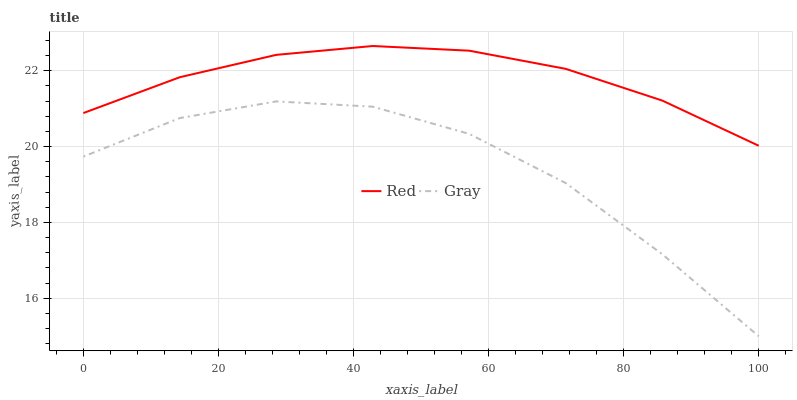Does Gray have the minimum area under the curve?
Answer yes or no. Yes. Does Red have the maximum area under the curve?
Answer yes or no. Yes. Does Red have the minimum area under the curve?
Answer yes or no. No. Is Red the smoothest?
Answer yes or no. Yes. Is Gray the roughest?
Answer yes or no. Yes. Is Red the roughest?
Answer yes or no. No. Does Gray have the lowest value?
Answer yes or no. Yes. Does Red have the lowest value?
Answer yes or no. No. Does Red have the highest value?
Answer yes or no. Yes. Is Gray less than Red?
Answer yes or no. Yes. Is Red greater than Gray?
Answer yes or no. Yes. Does Gray intersect Red?
Answer yes or no. No. 